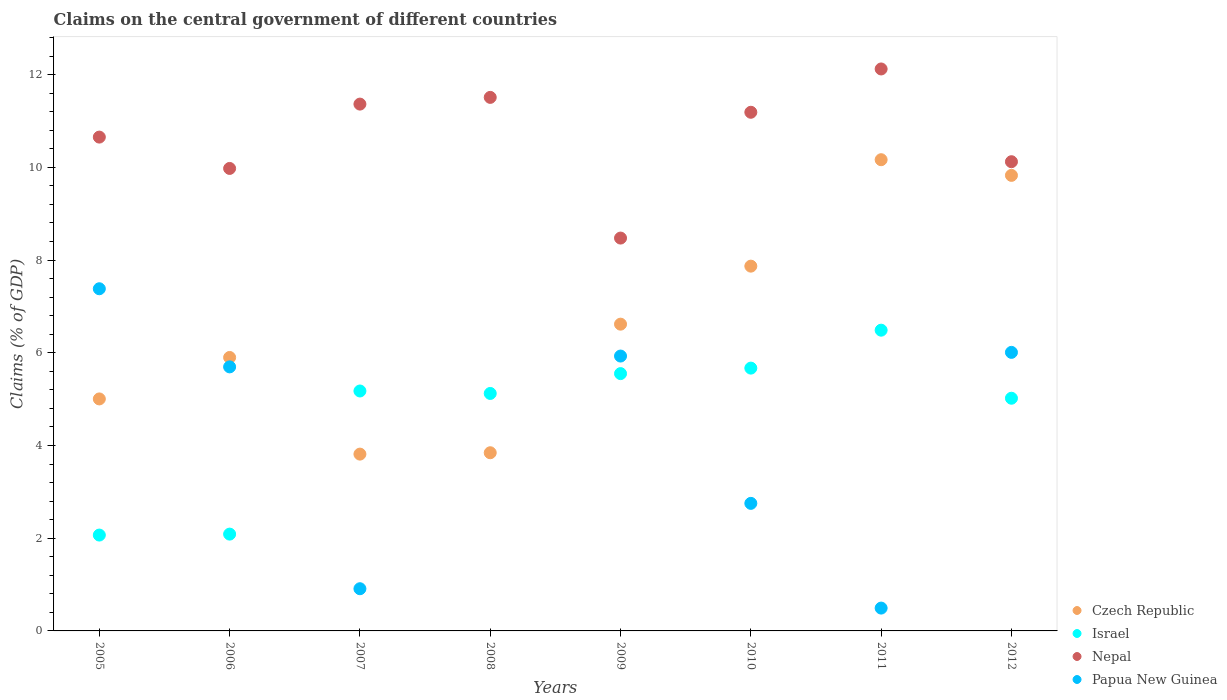How many different coloured dotlines are there?
Your response must be concise. 4. Is the number of dotlines equal to the number of legend labels?
Provide a succinct answer. No. What is the percentage of GDP claimed on the central government in Nepal in 2007?
Your response must be concise. 11.36. Across all years, what is the maximum percentage of GDP claimed on the central government in Israel?
Make the answer very short. 6.49. Across all years, what is the minimum percentage of GDP claimed on the central government in Israel?
Ensure brevity in your answer.  2.07. What is the total percentage of GDP claimed on the central government in Papua New Guinea in the graph?
Make the answer very short. 29.17. What is the difference between the percentage of GDP claimed on the central government in Czech Republic in 2009 and that in 2012?
Keep it short and to the point. -3.21. What is the difference between the percentage of GDP claimed on the central government in Israel in 2006 and the percentage of GDP claimed on the central government in Nepal in 2010?
Your response must be concise. -9.1. What is the average percentage of GDP claimed on the central government in Nepal per year?
Your answer should be very brief. 10.68. In the year 2010, what is the difference between the percentage of GDP claimed on the central government in Czech Republic and percentage of GDP claimed on the central government in Papua New Guinea?
Your response must be concise. 5.12. What is the ratio of the percentage of GDP claimed on the central government in Papua New Guinea in 2006 to that in 2010?
Your answer should be very brief. 2.07. Is the percentage of GDP claimed on the central government in Papua New Guinea in 2006 less than that in 2010?
Make the answer very short. No. What is the difference between the highest and the second highest percentage of GDP claimed on the central government in Papua New Guinea?
Your answer should be compact. 1.37. What is the difference between the highest and the lowest percentage of GDP claimed on the central government in Papua New Guinea?
Keep it short and to the point. 7.38. In how many years, is the percentage of GDP claimed on the central government in Israel greater than the average percentage of GDP claimed on the central government in Israel taken over all years?
Make the answer very short. 6. Is the sum of the percentage of GDP claimed on the central government in Czech Republic in 2006 and 2007 greater than the maximum percentage of GDP claimed on the central government in Papua New Guinea across all years?
Your answer should be compact. Yes. Is it the case that in every year, the sum of the percentage of GDP claimed on the central government in Papua New Guinea and percentage of GDP claimed on the central government in Czech Republic  is greater than the sum of percentage of GDP claimed on the central government in Israel and percentage of GDP claimed on the central government in Nepal?
Give a very brief answer. No. Is the percentage of GDP claimed on the central government in Israel strictly less than the percentage of GDP claimed on the central government in Nepal over the years?
Your response must be concise. Yes. How many years are there in the graph?
Keep it short and to the point. 8. What is the difference between two consecutive major ticks on the Y-axis?
Provide a succinct answer. 2. How are the legend labels stacked?
Give a very brief answer. Vertical. What is the title of the graph?
Offer a terse response. Claims on the central government of different countries. What is the label or title of the Y-axis?
Provide a succinct answer. Claims (% of GDP). What is the Claims (% of GDP) of Czech Republic in 2005?
Provide a short and direct response. 5. What is the Claims (% of GDP) of Israel in 2005?
Your answer should be compact. 2.07. What is the Claims (% of GDP) of Nepal in 2005?
Offer a terse response. 10.65. What is the Claims (% of GDP) in Papua New Guinea in 2005?
Offer a terse response. 7.38. What is the Claims (% of GDP) of Czech Republic in 2006?
Ensure brevity in your answer.  5.9. What is the Claims (% of GDP) of Israel in 2006?
Offer a very short reply. 2.09. What is the Claims (% of GDP) of Nepal in 2006?
Keep it short and to the point. 9.98. What is the Claims (% of GDP) in Papua New Guinea in 2006?
Your answer should be compact. 5.7. What is the Claims (% of GDP) of Czech Republic in 2007?
Provide a short and direct response. 3.81. What is the Claims (% of GDP) in Israel in 2007?
Offer a terse response. 5.18. What is the Claims (% of GDP) of Nepal in 2007?
Your answer should be compact. 11.36. What is the Claims (% of GDP) of Papua New Guinea in 2007?
Your response must be concise. 0.91. What is the Claims (% of GDP) of Czech Republic in 2008?
Provide a short and direct response. 3.84. What is the Claims (% of GDP) of Israel in 2008?
Your response must be concise. 5.12. What is the Claims (% of GDP) in Nepal in 2008?
Make the answer very short. 11.51. What is the Claims (% of GDP) in Papua New Guinea in 2008?
Offer a terse response. 0. What is the Claims (% of GDP) in Czech Republic in 2009?
Provide a succinct answer. 6.62. What is the Claims (% of GDP) of Israel in 2009?
Ensure brevity in your answer.  5.55. What is the Claims (% of GDP) of Nepal in 2009?
Give a very brief answer. 8.47. What is the Claims (% of GDP) of Papua New Guinea in 2009?
Provide a succinct answer. 5.93. What is the Claims (% of GDP) of Czech Republic in 2010?
Offer a terse response. 7.87. What is the Claims (% of GDP) in Israel in 2010?
Your answer should be compact. 5.67. What is the Claims (% of GDP) of Nepal in 2010?
Provide a short and direct response. 11.19. What is the Claims (% of GDP) in Papua New Guinea in 2010?
Ensure brevity in your answer.  2.75. What is the Claims (% of GDP) of Czech Republic in 2011?
Offer a very short reply. 10.16. What is the Claims (% of GDP) of Israel in 2011?
Your response must be concise. 6.49. What is the Claims (% of GDP) of Nepal in 2011?
Your answer should be very brief. 12.12. What is the Claims (% of GDP) in Papua New Guinea in 2011?
Offer a terse response. 0.49. What is the Claims (% of GDP) in Czech Republic in 2012?
Provide a succinct answer. 9.83. What is the Claims (% of GDP) in Israel in 2012?
Keep it short and to the point. 5.02. What is the Claims (% of GDP) in Nepal in 2012?
Provide a succinct answer. 10.12. What is the Claims (% of GDP) in Papua New Guinea in 2012?
Make the answer very short. 6.01. Across all years, what is the maximum Claims (% of GDP) of Czech Republic?
Your answer should be compact. 10.16. Across all years, what is the maximum Claims (% of GDP) of Israel?
Offer a terse response. 6.49. Across all years, what is the maximum Claims (% of GDP) in Nepal?
Your response must be concise. 12.12. Across all years, what is the maximum Claims (% of GDP) of Papua New Guinea?
Give a very brief answer. 7.38. Across all years, what is the minimum Claims (% of GDP) in Czech Republic?
Your response must be concise. 3.81. Across all years, what is the minimum Claims (% of GDP) in Israel?
Provide a succinct answer. 2.07. Across all years, what is the minimum Claims (% of GDP) of Nepal?
Give a very brief answer. 8.47. What is the total Claims (% of GDP) in Czech Republic in the graph?
Keep it short and to the point. 53.04. What is the total Claims (% of GDP) of Israel in the graph?
Make the answer very short. 37.18. What is the total Claims (% of GDP) of Nepal in the graph?
Your answer should be very brief. 85.41. What is the total Claims (% of GDP) of Papua New Guinea in the graph?
Your answer should be compact. 29.17. What is the difference between the Claims (% of GDP) of Czech Republic in 2005 and that in 2006?
Offer a very short reply. -0.89. What is the difference between the Claims (% of GDP) in Israel in 2005 and that in 2006?
Provide a succinct answer. -0.02. What is the difference between the Claims (% of GDP) of Nepal in 2005 and that in 2006?
Offer a very short reply. 0.68. What is the difference between the Claims (% of GDP) in Papua New Guinea in 2005 and that in 2006?
Provide a succinct answer. 1.69. What is the difference between the Claims (% of GDP) of Czech Republic in 2005 and that in 2007?
Keep it short and to the point. 1.19. What is the difference between the Claims (% of GDP) of Israel in 2005 and that in 2007?
Provide a short and direct response. -3.11. What is the difference between the Claims (% of GDP) of Nepal in 2005 and that in 2007?
Offer a very short reply. -0.71. What is the difference between the Claims (% of GDP) of Papua New Guinea in 2005 and that in 2007?
Your answer should be compact. 6.47. What is the difference between the Claims (% of GDP) of Czech Republic in 2005 and that in 2008?
Keep it short and to the point. 1.16. What is the difference between the Claims (% of GDP) of Israel in 2005 and that in 2008?
Your answer should be very brief. -3.05. What is the difference between the Claims (% of GDP) of Nepal in 2005 and that in 2008?
Make the answer very short. -0.86. What is the difference between the Claims (% of GDP) of Czech Republic in 2005 and that in 2009?
Provide a succinct answer. -1.61. What is the difference between the Claims (% of GDP) in Israel in 2005 and that in 2009?
Offer a very short reply. -3.48. What is the difference between the Claims (% of GDP) of Nepal in 2005 and that in 2009?
Provide a succinct answer. 2.18. What is the difference between the Claims (% of GDP) in Papua New Guinea in 2005 and that in 2009?
Offer a very short reply. 1.45. What is the difference between the Claims (% of GDP) of Czech Republic in 2005 and that in 2010?
Offer a terse response. -2.86. What is the difference between the Claims (% of GDP) of Israel in 2005 and that in 2010?
Provide a succinct answer. -3.6. What is the difference between the Claims (% of GDP) in Nepal in 2005 and that in 2010?
Provide a short and direct response. -0.54. What is the difference between the Claims (% of GDP) in Papua New Guinea in 2005 and that in 2010?
Keep it short and to the point. 4.63. What is the difference between the Claims (% of GDP) of Czech Republic in 2005 and that in 2011?
Ensure brevity in your answer.  -5.16. What is the difference between the Claims (% of GDP) in Israel in 2005 and that in 2011?
Your response must be concise. -4.42. What is the difference between the Claims (% of GDP) of Nepal in 2005 and that in 2011?
Provide a succinct answer. -1.47. What is the difference between the Claims (% of GDP) in Papua New Guinea in 2005 and that in 2011?
Your answer should be compact. 6.89. What is the difference between the Claims (% of GDP) in Czech Republic in 2005 and that in 2012?
Provide a succinct answer. -4.82. What is the difference between the Claims (% of GDP) of Israel in 2005 and that in 2012?
Your answer should be compact. -2.95. What is the difference between the Claims (% of GDP) of Nepal in 2005 and that in 2012?
Provide a short and direct response. 0.53. What is the difference between the Claims (% of GDP) of Papua New Guinea in 2005 and that in 2012?
Offer a very short reply. 1.37. What is the difference between the Claims (% of GDP) of Czech Republic in 2006 and that in 2007?
Ensure brevity in your answer.  2.08. What is the difference between the Claims (% of GDP) in Israel in 2006 and that in 2007?
Make the answer very short. -3.09. What is the difference between the Claims (% of GDP) in Nepal in 2006 and that in 2007?
Provide a succinct answer. -1.39. What is the difference between the Claims (% of GDP) of Papua New Guinea in 2006 and that in 2007?
Give a very brief answer. 4.79. What is the difference between the Claims (% of GDP) of Czech Republic in 2006 and that in 2008?
Your response must be concise. 2.06. What is the difference between the Claims (% of GDP) of Israel in 2006 and that in 2008?
Give a very brief answer. -3.03. What is the difference between the Claims (% of GDP) of Nepal in 2006 and that in 2008?
Your answer should be very brief. -1.53. What is the difference between the Claims (% of GDP) of Czech Republic in 2006 and that in 2009?
Give a very brief answer. -0.72. What is the difference between the Claims (% of GDP) in Israel in 2006 and that in 2009?
Make the answer very short. -3.46. What is the difference between the Claims (% of GDP) in Nepal in 2006 and that in 2009?
Your answer should be compact. 1.5. What is the difference between the Claims (% of GDP) in Papua New Guinea in 2006 and that in 2009?
Make the answer very short. -0.23. What is the difference between the Claims (% of GDP) of Czech Republic in 2006 and that in 2010?
Keep it short and to the point. -1.97. What is the difference between the Claims (% of GDP) of Israel in 2006 and that in 2010?
Offer a very short reply. -3.58. What is the difference between the Claims (% of GDP) of Nepal in 2006 and that in 2010?
Offer a very short reply. -1.21. What is the difference between the Claims (% of GDP) in Papua New Guinea in 2006 and that in 2010?
Make the answer very short. 2.94. What is the difference between the Claims (% of GDP) of Czech Republic in 2006 and that in 2011?
Your response must be concise. -4.27. What is the difference between the Claims (% of GDP) of Israel in 2006 and that in 2011?
Provide a short and direct response. -4.4. What is the difference between the Claims (% of GDP) in Nepal in 2006 and that in 2011?
Provide a short and direct response. -2.15. What is the difference between the Claims (% of GDP) of Papua New Guinea in 2006 and that in 2011?
Provide a short and direct response. 5.2. What is the difference between the Claims (% of GDP) of Czech Republic in 2006 and that in 2012?
Your answer should be compact. -3.93. What is the difference between the Claims (% of GDP) in Israel in 2006 and that in 2012?
Offer a terse response. -2.93. What is the difference between the Claims (% of GDP) of Nepal in 2006 and that in 2012?
Offer a very short reply. -0.15. What is the difference between the Claims (% of GDP) in Papua New Guinea in 2006 and that in 2012?
Keep it short and to the point. -0.31. What is the difference between the Claims (% of GDP) of Czech Republic in 2007 and that in 2008?
Offer a terse response. -0.03. What is the difference between the Claims (% of GDP) of Israel in 2007 and that in 2008?
Give a very brief answer. 0.05. What is the difference between the Claims (% of GDP) of Nepal in 2007 and that in 2008?
Give a very brief answer. -0.14. What is the difference between the Claims (% of GDP) of Czech Republic in 2007 and that in 2009?
Ensure brevity in your answer.  -2.8. What is the difference between the Claims (% of GDP) in Israel in 2007 and that in 2009?
Make the answer very short. -0.37. What is the difference between the Claims (% of GDP) of Nepal in 2007 and that in 2009?
Ensure brevity in your answer.  2.89. What is the difference between the Claims (% of GDP) in Papua New Guinea in 2007 and that in 2009?
Ensure brevity in your answer.  -5.02. What is the difference between the Claims (% of GDP) of Czech Republic in 2007 and that in 2010?
Provide a succinct answer. -4.05. What is the difference between the Claims (% of GDP) in Israel in 2007 and that in 2010?
Your response must be concise. -0.49. What is the difference between the Claims (% of GDP) in Nepal in 2007 and that in 2010?
Keep it short and to the point. 0.18. What is the difference between the Claims (% of GDP) of Papua New Guinea in 2007 and that in 2010?
Your response must be concise. -1.84. What is the difference between the Claims (% of GDP) in Czech Republic in 2007 and that in 2011?
Ensure brevity in your answer.  -6.35. What is the difference between the Claims (% of GDP) of Israel in 2007 and that in 2011?
Offer a very short reply. -1.31. What is the difference between the Claims (% of GDP) in Nepal in 2007 and that in 2011?
Give a very brief answer. -0.76. What is the difference between the Claims (% of GDP) in Papua New Guinea in 2007 and that in 2011?
Your answer should be compact. 0.42. What is the difference between the Claims (% of GDP) in Czech Republic in 2007 and that in 2012?
Keep it short and to the point. -6.01. What is the difference between the Claims (% of GDP) in Israel in 2007 and that in 2012?
Give a very brief answer. 0.16. What is the difference between the Claims (% of GDP) of Nepal in 2007 and that in 2012?
Provide a succinct answer. 1.24. What is the difference between the Claims (% of GDP) in Papua New Guinea in 2007 and that in 2012?
Ensure brevity in your answer.  -5.1. What is the difference between the Claims (% of GDP) of Czech Republic in 2008 and that in 2009?
Your answer should be compact. -2.77. What is the difference between the Claims (% of GDP) in Israel in 2008 and that in 2009?
Offer a terse response. -0.43. What is the difference between the Claims (% of GDP) in Nepal in 2008 and that in 2009?
Your response must be concise. 3.03. What is the difference between the Claims (% of GDP) in Czech Republic in 2008 and that in 2010?
Offer a terse response. -4.03. What is the difference between the Claims (% of GDP) in Israel in 2008 and that in 2010?
Offer a very short reply. -0.55. What is the difference between the Claims (% of GDP) of Nepal in 2008 and that in 2010?
Provide a short and direct response. 0.32. What is the difference between the Claims (% of GDP) of Czech Republic in 2008 and that in 2011?
Your answer should be very brief. -6.32. What is the difference between the Claims (% of GDP) of Israel in 2008 and that in 2011?
Make the answer very short. -1.36. What is the difference between the Claims (% of GDP) in Nepal in 2008 and that in 2011?
Your response must be concise. -0.61. What is the difference between the Claims (% of GDP) in Czech Republic in 2008 and that in 2012?
Ensure brevity in your answer.  -5.98. What is the difference between the Claims (% of GDP) of Israel in 2008 and that in 2012?
Provide a succinct answer. 0.1. What is the difference between the Claims (% of GDP) of Nepal in 2008 and that in 2012?
Make the answer very short. 1.39. What is the difference between the Claims (% of GDP) in Czech Republic in 2009 and that in 2010?
Offer a very short reply. -1.25. What is the difference between the Claims (% of GDP) in Israel in 2009 and that in 2010?
Offer a terse response. -0.12. What is the difference between the Claims (% of GDP) of Nepal in 2009 and that in 2010?
Provide a succinct answer. -2.71. What is the difference between the Claims (% of GDP) in Papua New Guinea in 2009 and that in 2010?
Give a very brief answer. 3.18. What is the difference between the Claims (% of GDP) in Czech Republic in 2009 and that in 2011?
Make the answer very short. -3.55. What is the difference between the Claims (% of GDP) in Israel in 2009 and that in 2011?
Ensure brevity in your answer.  -0.94. What is the difference between the Claims (% of GDP) of Nepal in 2009 and that in 2011?
Give a very brief answer. -3.65. What is the difference between the Claims (% of GDP) in Papua New Guinea in 2009 and that in 2011?
Your answer should be compact. 5.44. What is the difference between the Claims (% of GDP) in Czech Republic in 2009 and that in 2012?
Ensure brevity in your answer.  -3.21. What is the difference between the Claims (% of GDP) in Israel in 2009 and that in 2012?
Offer a very short reply. 0.53. What is the difference between the Claims (% of GDP) of Nepal in 2009 and that in 2012?
Your response must be concise. -1.65. What is the difference between the Claims (% of GDP) in Papua New Guinea in 2009 and that in 2012?
Your answer should be very brief. -0.08. What is the difference between the Claims (% of GDP) of Czech Republic in 2010 and that in 2011?
Your answer should be very brief. -2.3. What is the difference between the Claims (% of GDP) in Israel in 2010 and that in 2011?
Keep it short and to the point. -0.82. What is the difference between the Claims (% of GDP) in Nepal in 2010 and that in 2011?
Your response must be concise. -0.93. What is the difference between the Claims (% of GDP) in Papua New Guinea in 2010 and that in 2011?
Offer a terse response. 2.26. What is the difference between the Claims (% of GDP) in Czech Republic in 2010 and that in 2012?
Your answer should be very brief. -1.96. What is the difference between the Claims (% of GDP) of Israel in 2010 and that in 2012?
Your response must be concise. 0.65. What is the difference between the Claims (% of GDP) in Nepal in 2010 and that in 2012?
Your response must be concise. 1.07. What is the difference between the Claims (% of GDP) of Papua New Guinea in 2010 and that in 2012?
Your response must be concise. -3.26. What is the difference between the Claims (% of GDP) in Czech Republic in 2011 and that in 2012?
Your answer should be compact. 0.34. What is the difference between the Claims (% of GDP) in Israel in 2011 and that in 2012?
Provide a succinct answer. 1.47. What is the difference between the Claims (% of GDP) of Nepal in 2011 and that in 2012?
Give a very brief answer. 2. What is the difference between the Claims (% of GDP) in Papua New Guinea in 2011 and that in 2012?
Keep it short and to the point. -5.52. What is the difference between the Claims (% of GDP) of Czech Republic in 2005 and the Claims (% of GDP) of Israel in 2006?
Offer a very short reply. 2.92. What is the difference between the Claims (% of GDP) of Czech Republic in 2005 and the Claims (% of GDP) of Nepal in 2006?
Provide a short and direct response. -4.97. What is the difference between the Claims (% of GDP) of Czech Republic in 2005 and the Claims (% of GDP) of Papua New Guinea in 2006?
Ensure brevity in your answer.  -0.69. What is the difference between the Claims (% of GDP) of Israel in 2005 and the Claims (% of GDP) of Nepal in 2006?
Keep it short and to the point. -7.91. What is the difference between the Claims (% of GDP) in Israel in 2005 and the Claims (% of GDP) in Papua New Guinea in 2006?
Ensure brevity in your answer.  -3.63. What is the difference between the Claims (% of GDP) in Nepal in 2005 and the Claims (% of GDP) in Papua New Guinea in 2006?
Provide a succinct answer. 4.96. What is the difference between the Claims (% of GDP) in Czech Republic in 2005 and the Claims (% of GDP) in Israel in 2007?
Make the answer very short. -0.17. What is the difference between the Claims (% of GDP) of Czech Republic in 2005 and the Claims (% of GDP) of Nepal in 2007?
Offer a very short reply. -6.36. What is the difference between the Claims (% of GDP) of Czech Republic in 2005 and the Claims (% of GDP) of Papua New Guinea in 2007?
Offer a terse response. 4.09. What is the difference between the Claims (% of GDP) of Israel in 2005 and the Claims (% of GDP) of Nepal in 2007?
Offer a very short reply. -9.3. What is the difference between the Claims (% of GDP) of Israel in 2005 and the Claims (% of GDP) of Papua New Guinea in 2007?
Provide a short and direct response. 1.16. What is the difference between the Claims (% of GDP) in Nepal in 2005 and the Claims (% of GDP) in Papua New Guinea in 2007?
Give a very brief answer. 9.74. What is the difference between the Claims (% of GDP) of Czech Republic in 2005 and the Claims (% of GDP) of Israel in 2008?
Make the answer very short. -0.12. What is the difference between the Claims (% of GDP) in Czech Republic in 2005 and the Claims (% of GDP) in Nepal in 2008?
Your answer should be compact. -6.5. What is the difference between the Claims (% of GDP) in Israel in 2005 and the Claims (% of GDP) in Nepal in 2008?
Offer a very short reply. -9.44. What is the difference between the Claims (% of GDP) in Czech Republic in 2005 and the Claims (% of GDP) in Israel in 2009?
Your answer should be very brief. -0.55. What is the difference between the Claims (% of GDP) in Czech Republic in 2005 and the Claims (% of GDP) in Nepal in 2009?
Give a very brief answer. -3.47. What is the difference between the Claims (% of GDP) of Czech Republic in 2005 and the Claims (% of GDP) of Papua New Guinea in 2009?
Provide a succinct answer. -0.92. What is the difference between the Claims (% of GDP) in Israel in 2005 and the Claims (% of GDP) in Nepal in 2009?
Make the answer very short. -6.41. What is the difference between the Claims (% of GDP) of Israel in 2005 and the Claims (% of GDP) of Papua New Guinea in 2009?
Provide a succinct answer. -3.86. What is the difference between the Claims (% of GDP) in Nepal in 2005 and the Claims (% of GDP) in Papua New Guinea in 2009?
Your response must be concise. 4.72. What is the difference between the Claims (% of GDP) in Czech Republic in 2005 and the Claims (% of GDP) in Israel in 2010?
Keep it short and to the point. -0.66. What is the difference between the Claims (% of GDP) in Czech Republic in 2005 and the Claims (% of GDP) in Nepal in 2010?
Provide a short and direct response. -6.18. What is the difference between the Claims (% of GDP) of Czech Republic in 2005 and the Claims (% of GDP) of Papua New Guinea in 2010?
Your answer should be very brief. 2.25. What is the difference between the Claims (% of GDP) of Israel in 2005 and the Claims (% of GDP) of Nepal in 2010?
Your response must be concise. -9.12. What is the difference between the Claims (% of GDP) in Israel in 2005 and the Claims (% of GDP) in Papua New Guinea in 2010?
Make the answer very short. -0.68. What is the difference between the Claims (% of GDP) in Nepal in 2005 and the Claims (% of GDP) in Papua New Guinea in 2010?
Your answer should be very brief. 7.9. What is the difference between the Claims (% of GDP) in Czech Republic in 2005 and the Claims (% of GDP) in Israel in 2011?
Give a very brief answer. -1.48. What is the difference between the Claims (% of GDP) in Czech Republic in 2005 and the Claims (% of GDP) in Nepal in 2011?
Ensure brevity in your answer.  -7.12. What is the difference between the Claims (% of GDP) of Czech Republic in 2005 and the Claims (% of GDP) of Papua New Guinea in 2011?
Provide a short and direct response. 4.51. What is the difference between the Claims (% of GDP) in Israel in 2005 and the Claims (% of GDP) in Nepal in 2011?
Your answer should be very brief. -10.05. What is the difference between the Claims (% of GDP) in Israel in 2005 and the Claims (% of GDP) in Papua New Guinea in 2011?
Your answer should be compact. 1.58. What is the difference between the Claims (% of GDP) in Nepal in 2005 and the Claims (% of GDP) in Papua New Guinea in 2011?
Provide a short and direct response. 10.16. What is the difference between the Claims (% of GDP) in Czech Republic in 2005 and the Claims (% of GDP) in Israel in 2012?
Offer a terse response. -0.01. What is the difference between the Claims (% of GDP) of Czech Republic in 2005 and the Claims (% of GDP) of Nepal in 2012?
Make the answer very short. -5.12. What is the difference between the Claims (% of GDP) in Czech Republic in 2005 and the Claims (% of GDP) in Papua New Guinea in 2012?
Keep it short and to the point. -1. What is the difference between the Claims (% of GDP) of Israel in 2005 and the Claims (% of GDP) of Nepal in 2012?
Give a very brief answer. -8.05. What is the difference between the Claims (% of GDP) in Israel in 2005 and the Claims (% of GDP) in Papua New Guinea in 2012?
Your answer should be very brief. -3.94. What is the difference between the Claims (% of GDP) in Nepal in 2005 and the Claims (% of GDP) in Papua New Guinea in 2012?
Your answer should be compact. 4.64. What is the difference between the Claims (% of GDP) in Czech Republic in 2006 and the Claims (% of GDP) in Israel in 2007?
Your response must be concise. 0.72. What is the difference between the Claims (% of GDP) in Czech Republic in 2006 and the Claims (% of GDP) in Nepal in 2007?
Offer a very short reply. -5.47. What is the difference between the Claims (% of GDP) in Czech Republic in 2006 and the Claims (% of GDP) in Papua New Guinea in 2007?
Your answer should be compact. 4.99. What is the difference between the Claims (% of GDP) of Israel in 2006 and the Claims (% of GDP) of Nepal in 2007?
Ensure brevity in your answer.  -9.28. What is the difference between the Claims (% of GDP) of Israel in 2006 and the Claims (% of GDP) of Papua New Guinea in 2007?
Make the answer very short. 1.18. What is the difference between the Claims (% of GDP) in Nepal in 2006 and the Claims (% of GDP) in Papua New Guinea in 2007?
Offer a very short reply. 9.07. What is the difference between the Claims (% of GDP) of Czech Republic in 2006 and the Claims (% of GDP) of Israel in 2008?
Give a very brief answer. 0.78. What is the difference between the Claims (% of GDP) in Czech Republic in 2006 and the Claims (% of GDP) in Nepal in 2008?
Make the answer very short. -5.61. What is the difference between the Claims (% of GDP) in Israel in 2006 and the Claims (% of GDP) in Nepal in 2008?
Give a very brief answer. -9.42. What is the difference between the Claims (% of GDP) of Czech Republic in 2006 and the Claims (% of GDP) of Israel in 2009?
Your answer should be compact. 0.35. What is the difference between the Claims (% of GDP) of Czech Republic in 2006 and the Claims (% of GDP) of Nepal in 2009?
Provide a succinct answer. -2.58. What is the difference between the Claims (% of GDP) in Czech Republic in 2006 and the Claims (% of GDP) in Papua New Guinea in 2009?
Provide a succinct answer. -0.03. What is the difference between the Claims (% of GDP) of Israel in 2006 and the Claims (% of GDP) of Nepal in 2009?
Your response must be concise. -6.39. What is the difference between the Claims (% of GDP) in Israel in 2006 and the Claims (% of GDP) in Papua New Guinea in 2009?
Offer a very short reply. -3.84. What is the difference between the Claims (% of GDP) in Nepal in 2006 and the Claims (% of GDP) in Papua New Guinea in 2009?
Ensure brevity in your answer.  4.05. What is the difference between the Claims (% of GDP) in Czech Republic in 2006 and the Claims (% of GDP) in Israel in 2010?
Offer a terse response. 0.23. What is the difference between the Claims (% of GDP) in Czech Republic in 2006 and the Claims (% of GDP) in Nepal in 2010?
Provide a succinct answer. -5.29. What is the difference between the Claims (% of GDP) in Czech Republic in 2006 and the Claims (% of GDP) in Papua New Guinea in 2010?
Your answer should be very brief. 3.15. What is the difference between the Claims (% of GDP) of Israel in 2006 and the Claims (% of GDP) of Nepal in 2010?
Make the answer very short. -9.1. What is the difference between the Claims (% of GDP) of Israel in 2006 and the Claims (% of GDP) of Papua New Guinea in 2010?
Make the answer very short. -0.66. What is the difference between the Claims (% of GDP) in Nepal in 2006 and the Claims (% of GDP) in Papua New Guinea in 2010?
Offer a terse response. 7.22. What is the difference between the Claims (% of GDP) of Czech Republic in 2006 and the Claims (% of GDP) of Israel in 2011?
Ensure brevity in your answer.  -0.59. What is the difference between the Claims (% of GDP) in Czech Republic in 2006 and the Claims (% of GDP) in Nepal in 2011?
Provide a short and direct response. -6.22. What is the difference between the Claims (% of GDP) of Czech Republic in 2006 and the Claims (% of GDP) of Papua New Guinea in 2011?
Make the answer very short. 5.41. What is the difference between the Claims (% of GDP) in Israel in 2006 and the Claims (% of GDP) in Nepal in 2011?
Provide a short and direct response. -10.03. What is the difference between the Claims (% of GDP) in Israel in 2006 and the Claims (% of GDP) in Papua New Guinea in 2011?
Give a very brief answer. 1.6. What is the difference between the Claims (% of GDP) in Nepal in 2006 and the Claims (% of GDP) in Papua New Guinea in 2011?
Keep it short and to the point. 9.48. What is the difference between the Claims (% of GDP) in Czech Republic in 2006 and the Claims (% of GDP) in Israel in 2012?
Your response must be concise. 0.88. What is the difference between the Claims (% of GDP) in Czech Republic in 2006 and the Claims (% of GDP) in Nepal in 2012?
Give a very brief answer. -4.22. What is the difference between the Claims (% of GDP) in Czech Republic in 2006 and the Claims (% of GDP) in Papua New Guinea in 2012?
Provide a short and direct response. -0.11. What is the difference between the Claims (% of GDP) in Israel in 2006 and the Claims (% of GDP) in Nepal in 2012?
Provide a succinct answer. -8.03. What is the difference between the Claims (% of GDP) in Israel in 2006 and the Claims (% of GDP) in Papua New Guinea in 2012?
Give a very brief answer. -3.92. What is the difference between the Claims (% of GDP) of Nepal in 2006 and the Claims (% of GDP) of Papua New Guinea in 2012?
Provide a succinct answer. 3.97. What is the difference between the Claims (% of GDP) in Czech Republic in 2007 and the Claims (% of GDP) in Israel in 2008?
Ensure brevity in your answer.  -1.31. What is the difference between the Claims (% of GDP) in Czech Republic in 2007 and the Claims (% of GDP) in Nepal in 2008?
Keep it short and to the point. -7.7. What is the difference between the Claims (% of GDP) in Israel in 2007 and the Claims (% of GDP) in Nepal in 2008?
Make the answer very short. -6.33. What is the difference between the Claims (% of GDP) in Czech Republic in 2007 and the Claims (% of GDP) in Israel in 2009?
Provide a succinct answer. -1.74. What is the difference between the Claims (% of GDP) in Czech Republic in 2007 and the Claims (% of GDP) in Nepal in 2009?
Provide a succinct answer. -4.66. What is the difference between the Claims (% of GDP) in Czech Republic in 2007 and the Claims (% of GDP) in Papua New Guinea in 2009?
Offer a terse response. -2.12. What is the difference between the Claims (% of GDP) in Israel in 2007 and the Claims (% of GDP) in Nepal in 2009?
Keep it short and to the point. -3.3. What is the difference between the Claims (% of GDP) in Israel in 2007 and the Claims (% of GDP) in Papua New Guinea in 2009?
Ensure brevity in your answer.  -0.75. What is the difference between the Claims (% of GDP) of Nepal in 2007 and the Claims (% of GDP) of Papua New Guinea in 2009?
Keep it short and to the point. 5.43. What is the difference between the Claims (% of GDP) of Czech Republic in 2007 and the Claims (% of GDP) of Israel in 2010?
Offer a terse response. -1.86. What is the difference between the Claims (% of GDP) of Czech Republic in 2007 and the Claims (% of GDP) of Nepal in 2010?
Offer a very short reply. -7.37. What is the difference between the Claims (% of GDP) in Czech Republic in 2007 and the Claims (% of GDP) in Papua New Guinea in 2010?
Your response must be concise. 1.06. What is the difference between the Claims (% of GDP) of Israel in 2007 and the Claims (% of GDP) of Nepal in 2010?
Make the answer very short. -6.01. What is the difference between the Claims (% of GDP) in Israel in 2007 and the Claims (% of GDP) in Papua New Guinea in 2010?
Provide a short and direct response. 2.42. What is the difference between the Claims (% of GDP) in Nepal in 2007 and the Claims (% of GDP) in Papua New Guinea in 2010?
Provide a succinct answer. 8.61. What is the difference between the Claims (% of GDP) of Czech Republic in 2007 and the Claims (% of GDP) of Israel in 2011?
Give a very brief answer. -2.67. What is the difference between the Claims (% of GDP) of Czech Republic in 2007 and the Claims (% of GDP) of Nepal in 2011?
Offer a very short reply. -8.31. What is the difference between the Claims (% of GDP) of Czech Republic in 2007 and the Claims (% of GDP) of Papua New Guinea in 2011?
Your answer should be very brief. 3.32. What is the difference between the Claims (% of GDP) in Israel in 2007 and the Claims (% of GDP) in Nepal in 2011?
Provide a succinct answer. -6.95. What is the difference between the Claims (% of GDP) in Israel in 2007 and the Claims (% of GDP) in Papua New Guinea in 2011?
Keep it short and to the point. 4.68. What is the difference between the Claims (% of GDP) of Nepal in 2007 and the Claims (% of GDP) of Papua New Guinea in 2011?
Offer a terse response. 10.87. What is the difference between the Claims (% of GDP) of Czech Republic in 2007 and the Claims (% of GDP) of Israel in 2012?
Your response must be concise. -1.21. What is the difference between the Claims (% of GDP) in Czech Republic in 2007 and the Claims (% of GDP) in Nepal in 2012?
Give a very brief answer. -6.31. What is the difference between the Claims (% of GDP) in Czech Republic in 2007 and the Claims (% of GDP) in Papua New Guinea in 2012?
Your answer should be compact. -2.19. What is the difference between the Claims (% of GDP) of Israel in 2007 and the Claims (% of GDP) of Nepal in 2012?
Your answer should be compact. -4.95. What is the difference between the Claims (% of GDP) in Israel in 2007 and the Claims (% of GDP) in Papua New Guinea in 2012?
Your answer should be compact. -0.83. What is the difference between the Claims (% of GDP) of Nepal in 2007 and the Claims (% of GDP) of Papua New Guinea in 2012?
Make the answer very short. 5.36. What is the difference between the Claims (% of GDP) of Czech Republic in 2008 and the Claims (% of GDP) of Israel in 2009?
Ensure brevity in your answer.  -1.71. What is the difference between the Claims (% of GDP) in Czech Republic in 2008 and the Claims (% of GDP) in Nepal in 2009?
Your response must be concise. -4.63. What is the difference between the Claims (% of GDP) in Czech Republic in 2008 and the Claims (% of GDP) in Papua New Guinea in 2009?
Make the answer very short. -2.09. What is the difference between the Claims (% of GDP) of Israel in 2008 and the Claims (% of GDP) of Nepal in 2009?
Your answer should be compact. -3.35. What is the difference between the Claims (% of GDP) of Israel in 2008 and the Claims (% of GDP) of Papua New Guinea in 2009?
Offer a very short reply. -0.81. What is the difference between the Claims (% of GDP) of Nepal in 2008 and the Claims (% of GDP) of Papua New Guinea in 2009?
Your response must be concise. 5.58. What is the difference between the Claims (% of GDP) of Czech Republic in 2008 and the Claims (% of GDP) of Israel in 2010?
Make the answer very short. -1.83. What is the difference between the Claims (% of GDP) in Czech Republic in 2008 and the Claims (% of GDP) in Nepal in 2010?
Offer a very short reply. -7.34. What is the difference between the Claims (% of GDP) in Czech Republic in 2008 and the Claims (% of GDP) in Papua New Guinea in 2010?
Keep it short and to the point. 1.09. What is the difference between the Claims (% of GDP) in Israel in 2008 and the Claims (% of GDP) in Nepal in 2010?
Offer a terse response. -6.07. What is the difference between the Claims (% of GDP) of Israel in 2008 and the Claims (% of GDP) of Papua New Guinea in 2010?
Your answer should be very brief. 2.37. What is the difference between the Claims (% of GDP) in Nepal in 2008 and the Claims (% of GDP) in Papua New Guinea in 2010?
Your response must be concise. 8.76. What is the difference between the Claims (% of GDP) of Czech Republic in 2008 and the Claims (% of GDP) of Israel in 2011?
Ensure brevity in your answer.  -2.64. What is the difference between the Claims (% of GDP) in Czech Republic in 2008 and the Claims (% of GDP) in Nepal in 2011?
Your answer should be compact. -8.28. What is the difference between the Claims (% of GDP) of Czech Republic in 2008 and the Claims (% of GDP) of Papua New Guinea in 2011?
Your answer should be very brief. 3.35. What is the difference between the Claims (% of GDP) of Israel in 2008 and the Claims (% of GDP) of Nepal in 2011?
Provide a succinct answer. -7. What is the difference between the Claims (% of GDP) in Israel in 2008 and the Claims (% of GDP) in Papua New Guinea in 2011?
Your answer should be compact. 4.63. What is the difference between the Claims (% of GDP) of Nepal in 2008 and the Claims (% of GDP) of Papua New Guinea in 2011?
Your answer should be very brief. 11.02. What is the difference between the Claims (% of GDP) of Czech Republic in 2008 and the Claims (% of GDP) of Israel in 2012?
Offer a very short reply. -1.18. What is the difference between the Claims (% of GDP) of Czech Republic in 2008 and the Claims (% of GDP) of Nepal in 2012?
Provide a succinct answer. -6.28. What is the difference between the Claims (% of GDP) of Czech Republic in 2008 and the Claims (% of GDP) of Papua New Guinea in 2012?
Provide a succinct answer. -2.17. What is the difference between the Claims (% of GDP) in Israel in 2008 and the Claims (% of GDP) in Nepal in 2012?
Provide a short and direct response. -5. What is the difference between the Claims (% of GDP) of Israel in 2008 and the Claims (% of GDP) of Papua New Guinea in 2012?
Provide a short and direct response. -0.89. What is the difference between the Claims (% of GDP) in Nepal in 2008 and the Claims (% of GDP) in Papua New Guinea in 2012?
Your answer should be very brief. 5.5. What is the difference between the Claims (% of GDP) of Czech Republic in 2009 and the Claims (% of GDP) of Israel in 2010?
Your response must be concise. 0.95. What is the difference between the Claims (% of GDP) in Czech Republic in 2009 and the Claims (% of GDP) in Nepal in 2010?
Your answer should be very brief. -4.57. What is the difference between the Claims (% of GDP) of Czech Republic in 2009 and the Claims (% of GDP) of Papua New Guinea in 2010?
Ensure brevity in your answer.  3.87. What is the difference between the Claims (% of GDP) of Israel in 2009 and the Claims (% of GDP) of Nepal in 2010?
Give a very brief answer. -5.64. What is the difference between the Claims (% of GDP) of Israel in 2009 and the Claims (% of GDP) of Papua New Guinea in 2010?
Offer a terse response. 2.8. What is the difference between the Claims (% of GDP) in Nepal in 2009 and the Claims (% of GDP) in Papua New Guinea in 2010?
Make the answer very short. 5.72. What is the difference between the Claims (% of GDP) of Czech Republic in 2009 and the Claims (% of GDP) of Israel in 2011?
Your answer should be compact. 0.13. What is the difference between the Claims (% of GDP) of Czech Republic in 2009 and the Claims (% of GDP) of Nepal in 2011?
Your response must be concise. -5.51. What is the difference between the Claims (% of GDP) of Czech Republic in 2009 and the Claims (% of GDP) of Papua New Guinea in 2011?
Offer a very short reply. 6.12. What is the difference between the Claims (% of GDP) of Israel in 2009 and the Claims (% of GDP) of Nepal in 2011?
Ensure brevity in your answer.  -6.57. What is the difference between the Claims (% of GDP) of Israel in 2009 and the Claims (% of GDP) of Papua New Guinea in 2011?
Give a very brief answer. 5.06. What is the difference between the Claims (% of GDP) of Nepal in 2009 and the Claims (% of GDP) of Papua New Guinea in 2011?
Offer a terse response. 7.98. What is the difference between the Claims (% of GDP) of Czech Republic in 2009 and the Claims (% of GDP) of Israel in 2012?
Your answer should be very brief. 1.6. What is the difference between the Claims (% of GDP) in Czech Republic in 2009 and the Claims (% of GDP) in Nepal in 2012?
Provide a short and direct response. -3.5. What is the difference between the Claims (% of GDP) in Czech Republic in 2009 and the Claims (% of GDP) in Papua New Guinea in 2012?
Offer a very short reply. 0.61. What is the difference between the Claims (% of GDP) of Israel in 2009 and the Claims (% of GDP) of Nepal in 2012?
Provide a short and direct response. -4.57. What is the difference between the Claims (% of GDP) of Israel in 2009 and the Claims (% of GDP) of Papua New Guinea in 2012?
Make the answer very short. -0.46. What is the difference between the Claims (% of GDP) of Nepal in 2009 and the Claims (% of GDP) of Papua New Guinea in 2012?
Make the answer very short. 2.47. What is the difference between the Claims (% of GDP) of Czech Republic in 2010 and the Claims (% of GDP) of Israel in 2011?
Give a very brief answer. 1.38. What is the difference between the Claims (% of GDP) in Czech Republic in 2010 and the Claims (% of GDP) in Nepal in 2011?
Provide a succinct answer. -4.25. What is the difference between the Claims (% of GDP) of Czech Republic in 2010 and the Claims (% of GDP) of Papua New Guinea in 2011?
Offer a terse response. 7.38. What is the difference between the Claims (% of GDP) of Israel in 2010 and the Claims (% of GDP) of Nepal in 2011?
Offer a very short reply. -6.45. What is the difference between the Claims (% of GDP) in Israel in 2010 and the Claims (% of GDP) in Papua New Guinea in 2011?
Your answer should be compact. 5.18. What is the difference between the Claims (% of GDP) of Nepal in 2010 and the Claims (% of GDP) of Papua New Guinea in 2011?
Keep it short and to the point. 10.7. What is the difference between the Claims (% of GDP) of Czech Republic in 2010 and the Claims (% of GDP) of Israel in 2012?
Make the answer very short. 2.85. What is the difference between the Claims (% of GDP) of Czech Republic in 2010 and the Claims (% of GDP) of Nepal in 2012?
Give a very brief answer. -2.25. What is the difference between the Claims (% of GDP) in Czech Republic in 2010 and the Claims (% of GDP) in Papua New Guinea in 2012?
Your answer should be very brief. 1.86. What is the difference between the Claims (% of GDP) in Israel in 2010 and the Claims (% of GDP) in Nepal in 2012?
Ensure brevity in your answer.  -4.45. What is the difference between the Claims (% of GDP) in Israel in 2010 and the Claims (% of GDP) in Papua New Guinea in 2012?
Provide a short and direct response. -0.34. What is the difference between the Claims (% of GDP) in Nepal in 2010 and the Claims (% of GDP) in Papua New Guinea in 2012?
Provide a short and direct response. 5.18. What is the difference between the Claims (% of GDP) of Czech Republic in 2011 and the Claims (% of GDP) of Israel in 2012?
Provide a succinct answer. 5.15. What is the difference between the Claims (% of GDP) in Czech Republic in 2011 and the Claims (% of GDP) in Nepal in 2012?
Ensure brevity in your answer.  0.04. What is the difference between the Claims (% of GDP) in Czech Republic in 2011 and the Claims (% of GDP) in Papua New Guinea in 2012?
Provide a short and direct response. 4.16. What is the difference between the Claims (% of GDP) in Israel in 2011 and the Claims (% of GDP) in Nepal in 2012?
Give a very brief answer. -3.63. What is the difference between the Claims (% of GDP) in Israel in 2011 and the Claims (% of GDP) in Papua New Guinea in 2012?
Keep it short and to the point. 0.48. What is the difference between the Claims (% of GDP) in Nepal in 2011 and the Claims (% of GDP) in Papua New Guinea in 2012?
Provide a succinct answer. 6.11. What is the average Claims (% of GDP) in Czech Republic per year?
Your answer should be compact. 6.63. What is the average Claims (% of GDP) of Israel per year?
Keep it short and to the point. 4.65. What is the average Claims (% of GDP) in Nepal per year?
Provide a short and direct response. 10.68. What is the average Claims (% of GDP) of Papua New Guinea per year?
Provide a succinct answer. 3.65. In the year 2005, what is the difference between the Claims (% of GDP) in Czech Republic and Claims (% of GDP) in Israel?
Keep it short and to the point. 2.94. In the year 2005, what is the difference between the Claims (% of GDP) in Czech Republic and Claims (% of GDP) in Nepal?
Keep it short and to the point. -5.65. In the year 2005, what is the difference between the Claims (% of GDP) of Czech Republic and Claims (% of GDP) of Papua New Guinea?
Make the answer very short. -2.38. In the year 2005, what is the difference between the Claims (% of GDP) of Israel and Claims (% of GDP) of Nepal?
Your response must be concise. -8.58. In the year 2005, what is the difference between the Claims (% of GDP) of Israel and Claims (% of GDP) of Papua New Guinea?
Make the answer very short. -5.31. In the year 2005, what is the difference between the Claims (% of GDP) in Nepal and Claims (% of GDP) in Papua New Guinea?
Make the answer very short. 3.27. In the year 2006, what is the difference between the Claims (% of GDP) in Czech Republic and Claims (% of GDP) in Israel?
Keep it short and to the point. 3.81. In the year 2006, what is the difference between the Claims (% of GDP) in Czech Republic and Claims (% of GDP) in Nepal?
Ensure brevity in your answer.  -4.08. In the year 2006, what is the difference between the Claims (% of GDP) in Czech Republic and Claims (% of GDP) in Papua New Guinea?
Your answer should be very brief. 0.2. In the year 2006, what is the difference between the Claims (% of GDP) in Israel and Claims (% of GDP) in Nepal?
Keep it short and to the point. -7.89. In the year 2006, what is the difference between the Claims (% of GDP) in Israel and Claims (% of GDP) in Papua New Guinea?
Give a very brief answer. -3.61. In the year 2006, what is the difference between the Claims (% of GDP) of Nepal and Claims (% of GDP) of Papua New Guinea?
Ensure brevity in your answer.  4.28. In the year 2007, what is the difference between the Claims (% of GDP) of Czech Republic and Claims (% of GDP) of Israel?
Ensure brevity in your answer.  -1.36. In the year 2007, what is the difference between the Claims (% of GDP) of Czech Republic and Claims (% of GDP) of Nepal?
Provide a short and direct response. -7.55. In the year 2007, what is the difference between the Claims (% of GDP) of Czech Republic and Claims (% of GDP) of Papua New Guinea?
Your response must be concise. 2.9. In the year 2007, what is the difference between the Claims (% of GDP) in Israel and Claims (% of GDP) in Nepal?
Offer a terse response. -6.19. In the year 2007, what is the difference between the Claims (% of GDP) in Israel and Claims (% of GDP) in Papua New Guinea?
Offer a very short reply. 4.27. In the year 2007, what is the difference between the Claims (% of GDP) in Nepal and Claims (% of GDP) in Papua New Guinea?
Your response must be concise. 10.45. In the year 2008, what is the difference between the Claims (% of GDP) in Czech Republic and Claims (% of GDP) in Israel?
Ensure brevity in your answer.  -1.28. In the year 2008, what is the difference between the Claims (% of GDP) in Czech Republic and Claims (% of GDP) in Nepal?
Offer a terse response. -7.67. In the year 2008, what is the difference between the Claims (% of GDP) of Israel and Claims (% of GDP) of Nepal?
Offer a terse response. -6.39. In the year 2009, what is the difference between the Claims (% of GDP) in Czech Republic and Claims (% of GDP) in Israel?
Your response must be concise. 1.07. In the year 2009, what is the difference between the Claims (% of GDP) in Czech Republic and Claims (% of GDP) in Nepal?
Provide a succinct answer. -1.86. In the year 2009, what is the difference between the Claims (% of GDP) in Czech Republic and Claims (% of GDP) in Papua New Guinea?
Provide a succinct answer. 0.69. In the year 2009, what is the difference between the Claims (% of GDP) in Israel and Claims (% of GDP) in Nepal?
Give a very brief answer. -2.92. In the year 2009, what is the difference between the Claims (% of GDP) of Israel and Claims (% of GDP) of Papua New Guinea?
Your response must be concise. -0.38. In the year 2009, what is the difference between the Claims (% of GDP) in Nepal and Claims (% of GDP) in Papua New Guinea?
Your answer should be very brief. 2.55. In the year 2010, what is the difference between the Claims (% of GDP) in Czech Republic and Claims (% of GDP) in Israel?
Offer a terse response. 2.2. In the year 2010, what is the difference between the Claims (% of GDP) of Czech Republic and Claims (% of GDP) of Nepal?
Your answer should be compact. -3.32. In the year 2010, what is the difference between the Claims (% of GDP) of Czech Republic and Claims (% of GDP) of Papua New Guinea?
Make the answer very short. 5.12. In the year 2010, what is the difference between the Claims (% of GDP) in Israel and Claims (% of GDP) in Nepal?
Your answer should be compact. -5.52. In the year 2010, what is the difference between the Claims (% of GDP) of Israel and Claims (% of GDP) of Papua New Guinea?
Your response must be concise. 2.92. In the year 2010, what is the difference between the Claims (% of GDP) of Nepal and Claims (% of GDP) of Papua New Guinea?
Your answer should be very brief. 8.44. In the year 2011, what is the difference between the Claims (% of GDP) in Czech Republic and Claims (% of GDP) in Israel?
Give a very brief answer. 3.68. In the year 2011, what is the difference between the Claims (% of GDP) of Czech Republic and Claims (% of GDP) of Nepal?
Your response must be concise. -1.96. In the year 2011, what is the difference between the Claims (% of GDP) of Czech Republic and Claims (% of GDP) of Papua New Guinea?
Your answer should be very brief. 9.67. In the year 2011, what is the difference between the Claims (% of GDP) of Israel and Claims (% of GDP) of Nepal?
Provide a short and direct response. -5.63. In the year 2011, what is the difference between the Claims (% of GDP) in Israel and Claims (% of GDP) in Papua New Guinea?
Offer a very short reply. 5.99. In the year 2011, what is the difference between the Claims (% of GDP) in Nepal and Claims (% of GDP) in Papua New Guinea?
Your response must be concise. 11.63. In the year 2012, what is the difference between the Claims (% of GDP) in Czech Republic and Claims (% of GDP) in Israel?
Your response must be concise. 4.81. In the year 2012, what is the difference between the Claims (% of GDP) in Czech Republic and Claims (% of GDP) in Nepal?
Offer a terse response. -0.29. In the year 2012, what is the difference between the Claims (% of GDP) in Czech Republic and Claims (% of GDP) in Papua New Guinea?
Your response must be concise. 3.82. In the year 2012, what is the difference between the Claims (% of GDP) in Israel and Claims (% of GDP) in Nepal?
Your response must be concise. -5.1. In the year 2012, what is the difference between the Claims (% of GDP) in Israel and Claims (% of GDP) in Papua New Guinea?
Offer a very short reply. -0.99. In the year 2012, what is the difference between the Claims (% of GDP) in Nepal and Claims (% of GDP) in Papua New Guinea?
Provide a short and direct response. 4.11. What is the ratio of the Claims (% of GDP) of Czech Republic in 2005 to that in 2006?
Give a very brief answer. 0.85. What is the ratio of the Claims (% of GDP) in Nepal in 2005 to that in 2006?
Ensure brevity in your answer.  1.07. What is the ratio of the Claims (% of GDP) of Papua New Guinea in 2005 to that in 2006?
Your answer should be very brief. 1.3. What is the ratio of the Claims (% of GDP) of Czech Republic in 2005 to that in 2007?
Your answer should be very brief. 1.31. What is the ratio of the Claims (% of GDP) of Israel in 2005 to that in 2007?
Give a very brief answer. 0.4. What is the ratio of the Claims (% of GDP) of Nepal in 2005 to that in 2007?
Keep it short and to the point. 0.94. What is the ratio of the Claims (% of GDP) of Papua New Guinea in 2005 to that in 2007?
Your response must be concise. 8.11. What is the ratio of the Claims (% of GDP) of Czech Republic in 2005 to that in 2008?
Your response must be concise. 1.3. What is the ratio of the Claims (% of GDP) of Israel in 2005 to that in 2008?
Make the answer very short. 0.4. What is the ratio of the Claims (% of GDP) in Nepal in 2005 to that in 2008?
Make the answer very short. 0.93. What is the ratio of the Claims (% of GDP) in Czech Republic in 2005 to that in 2009?
Ensure brevity in your answer.  0.76. What is the ratio of the Claims (% of GDP) in Israel in 2005 to that in 2009?
Keep it short and to the point. 0.37. What is the ratio of the Claims (% of GDP) of Nepal in 2005 to that in 2009?
Your answer should be compact. 1.26. What is the ratio of the Claims (% of GDP) of Papua New Guinea in 2005 to that in 2009?
Offer a terse response. 1.24. What is the ratio of the Claims (% of GDP) in Czech Republic in 2005 to that in 2010?
Your answer should be compact. 0.64. What is the ratio of the Claims (% of GDP) in Israel in 2005 to that in 2010?
Give a very brief answer. 0.36. What is the ratio of the Claims (% of GDP) in Nepal in 2005 to that in 2010?
Your answer should be very brief. 0.95. What is the ratio of the Claims (% of GDP) in Papua New Guinea in 2005 to that in 2010?
Your answer should be compact. 2.68. What is the ratio of the Claims (% of GDP) in Czech Republic in 2005 to that in 2011?
Ensure brevity in your answer.  0.49. What is the ratio of the Claims (% of GDP) of Israel in 2005 to that in 2011?
Make the answer very short. 0.32. What is the ratio of the Claims (% of GDP) of Nepal in 2005 to that in 2011?
Your answer should be compact. 0.88. What is the ratio of the Claims (% of GDP) of Papua New Guinea in 2005 to that in 2011?
Offer a very short reply. 14.99. What is the ratio of the Claims (% of GDP) in Czech Republic in 2005 to that in 2012?
Your answer should be very brief. 0.51. What is the ratio of the Claims (% of GDP) of Israel in 2005 to that in 2012?
Your answer should be very brief. 0.41. What is the ratio of the Claims (% of GDP) of Nepal in 2005 to that in 2012?
Keep it short and to the point. 1.05. What is the ratio of the Claims (% of GDP) in Papua New Guinea in 2005 to that in 2012?
Offer a very short reply. 1.23. What is the ratio of the Claims (% of GDP) of Czech Republic in 2006 to that in 2007?
Offer a terse response. 1.55. What is the ratio of the Claims (% of GDP) of Israel in 2006 to that in 2007?
Your answer should be very brief. 0.4. What is the ratio of the Claims (% of GDP) in Nepal in 2006 to that in 2007?
Offer a very short reply. 0.88. What is the ratio of the Claims (% of GDP) in Papua New Guinea in 2006 to that in 2007?
Your answer should be compact. 6.26. What is the ratio of the Claims (% of GDP) of Czech Republic in 2006 to that in 2008?
Your response must be concise. 1.53. What is the ratio of the Claims (% of GDP) in Israel in 2006 to that in 2008?
Make the answer very short. 0.41. What is the ratio of the Claims (% of GDP) of Nepal in 2006 to that in 2008?
Your answer should be compact. 0.87. What is the ratio of the Claims (% of GDP) of Czech Republic in 2006 to that in 2009?
Provide a short and direct response. 0.89. What is the ratio of the Claims (% of GDP) in Israel in 2006 to that in 2009?
Provide a short and direct response. 0.38. What is the ratio of the Claims (% of GDP) in Nepal in 2006 to that in 2009?
Your answer should be very brief. 1.18. What is the ratio of the Claims (% of GDP) in Papua New Guinea in 2006 to that in 2009?
Your response must be concise. 0.96. What is the ratio of the Claims (% of GDP) of Czech Republic in 2006 to that in 2010?
Give a very brief answer. 0.75. What is the ratio of the Claims (% of GDP) in Israel in 2006 to that in 2010?
Your response must be concise. 0.37. What is the ratio of the Claims (% of GDP) of Nepal in 2006 to that in 2010?
Offer a very short reply. 0.89. What is the ratio of the Claims (% of GDP) of Papua New Guinea in 2006 to that in 2010?
Your response must be concise. 2.07. What is the ratio of the Claims (% of GDP) in Czech Republic in 2006 to that in 2011?
Keep it short and to the point. 0.58. What is the ratio of the Claims (% of GDP) in Israel in 2006 to that in 2011?
Your answer should be very brief. 0.32. What is the ratio of the Claims (% of GDP) of Nepal in 2006 to that in 2011?
Your answer should be compact. 0.82. What is the ratio of the Claims (% of GDP) of Papua New Guinea in 2006 to that in 2011?
Your answer should be compact. 11.57. What is the ratio of the Claims (% of GDP) in Czech Republic in 2006 to that in 2012?
Your answer should be compact. 0.6. What is the ratio of the Claims (% of GDP) in Israel in 2006 to that in 2012?
Your answer should be very brief. 0.42. What is the ratio of the Claims (% of GDP) in Nepal in 2006 to that in 2012?
Your answer should be compact. 0.99. What is the ratio of the Claims (% of GDP) in Papua New Guinea in 2006 to that in 2012?
Give a very brief answer. 0.95. What is the ratio of the Claims (% of GDP) in Israel in 2007 to that in 2008?
Offer a very short reply. 1.01. What is the ratio of the Claims (% of GDP) of Nepal in 2007 to that in 2008?
Your answer should be very brief. 0.99. What is the ratio of the Claims (% of GDP) in Czech Republic in 2007 to that in 2009?
Your response must be concise. 0.58. What is the ratio of the Claims (% of GDP) in Israel in 2007 to that in 2009?
Give a very brief answer. 0.93. What is the ratio of the Claims (% of GDP) of Nepal in 2007 to that in 2009?
Your response must be concise. 1.34. What is the ratio of the Claims (% of GDP) of Papua New Guinea in 2007 to that in 2009?
Make the answer very short. 0.15. What is the ratio of the Claims (% of GDP) in Czech Republic in 2007 to that in 2010?
Your response must be concise. 0.48. What is the ratio of the Claims (% of GDP) of Israel in 2007 to that in 2010?
Make the answer very short. 0.91. What is the ratio of the Claims (% of GDP) of Nepal in 2007 to that in 2010?
Provide a short and direct response. 1.02. What is the ratio of the Claims (% of GDP) in Papua New Guinea in 2007 to that in 2010?
Offer a terse response. 0.33. What is the ratio of the Claims (% of GDP) in Czech Republic in 2007 to that in 2011?
Your answer should be very brief. 0.38. What is the ratio of the Claims (% of GDP) in Israel in 2007 to that in 2011?
Offer a terse response. 0.8. What is the ratio of the Claims (% of GDP) of Nepal in 2007 to that in 2011?
Your answer should be compact. 0.94. What is the ratio of the Claims (% of GDP) in Papua New Guinea in 2007 to that in 2011?
Ensure brevity in your answer.  1.85. What is the ratio of the Claims (% of GDP) in Czech Republic in 2007 to that in 2012?
Your answer should be compact. 0.39. What is the ratio of the Claims (% of GDP) in Israel in 2007 to that in 2012?
Keep it short and to the point. 1.03. What is the ratio of the Claims (% of GDP) of Nepal in 2007 to that in 2012?
Offer a very short reply. 1.12. What is the ratio of the Claims (% of GDP) in Papua New Guinea in 2007 to that in 2012?
Ensure brevity in your answer.  0.15. What is the ratio of the Claims (% of GDP) in Czech Republic in 2008 to that in 2009?
Your response must be concise. 0.58. What is the ratio of the Claims (% of GDP) of Israel in 2008 to that in 2009?
Make the answer very short. 0.92. What is the ratio of the Claims (% of GDP) of Nepal in 2008 to that in 2009?
Provide a short and direct response. 1.36. What is the ratio of the Claims (% of GDP) of Czech Republic in 2008 to that in 2010?
Provide a succinct answer. 0.49. What is the ratio of the Claims (% of GDP) of Israel in 2008 to that in 2010?
Offer a terse response. 0.9. What is the ratio of the Claims (% of GDP) in Nepal in 2008 to that in 2010?
Offer a terse response. 1.03. What is the ratio of the Claims (% of GDP) of Czech Republic in 2008 to that in 2011?
Provide a short and direct response. 0.38. What is the ratio of the Claims (% of GDP) in Israel in 2008 to that in 2011?
Provide a short and direct response. 0.79. What is the ratio of the Claims (% of GDP) of Nepal in 2008 to that in 2011?
Make the answer very short. 0.95. What is the ratio of the Claims (% of GDP) of Czech Republic in 2008 to that in 2012?
Offer a very short reply. 0.39. What is the ratio of the Claims (% of GDP) in Israel in 2008 to that in 2012?
Provide a short and direct response. 1.02. What is the ratio of the Claims (% of GDP) in Nepal in 2008 to that in 2012?
Ensure brevity in your answer.  1.14. What is the ratio of the Claims (% of GDP) in Czech Republic in 2009 to that in 2010?
Ensure brevity in your answer.  0.84. What is the ratio of the Claims (% of GDP) of Israel in 2009 to that in 2010?
Ensure brevity in your answer.  0.98. What is the ratio of the Claims (% of GDP) in Nepal in 2009 to that in 2010?
Make the answer very short. 0.76. What is the ratio of the Claims (% of GDP) in Papua New Guinea in 2009 to that in 2010?
Make the answer very short. 2.15. What is the ratio of the Claims (% of GDP) in Czech Republic in 2009 to that in 2011?
Ensure brevity in your answer.  0.65. What is the ratio of the Claims (% of GDP) in Israel in 2009 to that in 2011?
Ensure brevity in your answer.  0.86. What is the ratio of the Claims (% of GDP) in Nepal in 2009 to that in 2011?
Your answer should be compact. 0.7. What is the ratio of the Claims (% of GDP) of Papua New Guinea in 2009 to that in 2011?
Ensure brevity in your answer.  12.04. What is the ratio of the Claims (% of GDP) of Czech Republic in 2009 to that in 2012?
Ensure brevity in your answer.  0.67. What is the ratio of the Claims (% of GDP) of Israel in 2009 to that in 2012?
Your answer should be very brief. 1.11. What is the ratio of the Claims (% of GDP) of Nepal in 2009 to that in 2012?
Your response must be concise. 0.84. What is the ratio of the Claims (% of GDP) in Czech Republic in 2010 to that in 2011?
Your answer should be compact. 0.77. What is the ratio of the Claims (% of GDP) of Israel in 2010 to that in 2011?
Ensure brevity in your answer.  0.87. What is the ratio of the Claims (% of GDP) in Nepal in 2010 to that in 2011?
Provide a succinct answer. 0.92. What is the ratio of the Claims (% of GDP) in Papua New Guinea in 2010 to that in 2011?
Make the answer very short. 5.59. What is the ratio of the Claims (% of GDP) in Czech Republic in 2010 to that in 2012?
Your answer should be very brief. 0.8. What is the ratio of the Claims (% of GDP) of Israel in 2010 to that in 2012?
Provide a short and direct response. 1.13. What is the ratio of the Claims (% of GDP) of Nepal in 2010 to that in 2012?
Keep it short and to the point. 1.11. What is the ratio of the Claims (% of GDP) of Papua New Guinea in 2010 to that in 2012?
Your response must be concise. 0.46. What is the ratio of the Claims (% of GDP) of Czech Republic in 2011 to that in 2012?
Make the answer very short. 1.03. What is the ratio of the Claims (% of GDP) in Israel in 2011 to that in 2012?
Your answer should be very brief. 1.29. What is the ratio of the Claims (% of GDP) of Nepal in 2011 to that in 2012?
Your answer should be very brief. 1.2. What is the ratio of the Claims (% of GDP) in Papua New Guinea in 2011 to that in 2012?
Ensure brevity in your answer.  0.08. What is the difference between the highest and the second highest Claims (% of GDP) of Czech Republic?
Make the answer very short. 0.34. What is the difference between the highest and the second highest Claims (% of GDP) of Israel?
Your answer should be compact. 0.82. What is the difference between the highest and the second highest Claims (% of GDP) in Nepal?
Your answer should be compact. 0.61. What is the difference between the highest and the second highest Claims (% of GDP) in Papua New Guinea?
Make the answer very short. 1.37. What is the difference between the highest and the lowest Claims (% of GDP) of Czech Republic?
Provide a short and direct response. 6.35. What is the difference between the highest and the lowest Claims (% of GDP) in Israel?
Your response must be concise. 4.42. What is the difference between the highest and the lowest Claims (% of GDP) in Nepal?
Make the answer very short. 3.65. What is the difference between the highest and the lowest Claims (% of GDP) in Papua New Guinea?
Ensure brevity in your answer.  7.38. 